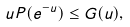<formula> <loc_0><loc_0><loc_500><loc_500>u P ( e ^ { - u } ) \leq G ( u ) ,</formula> 